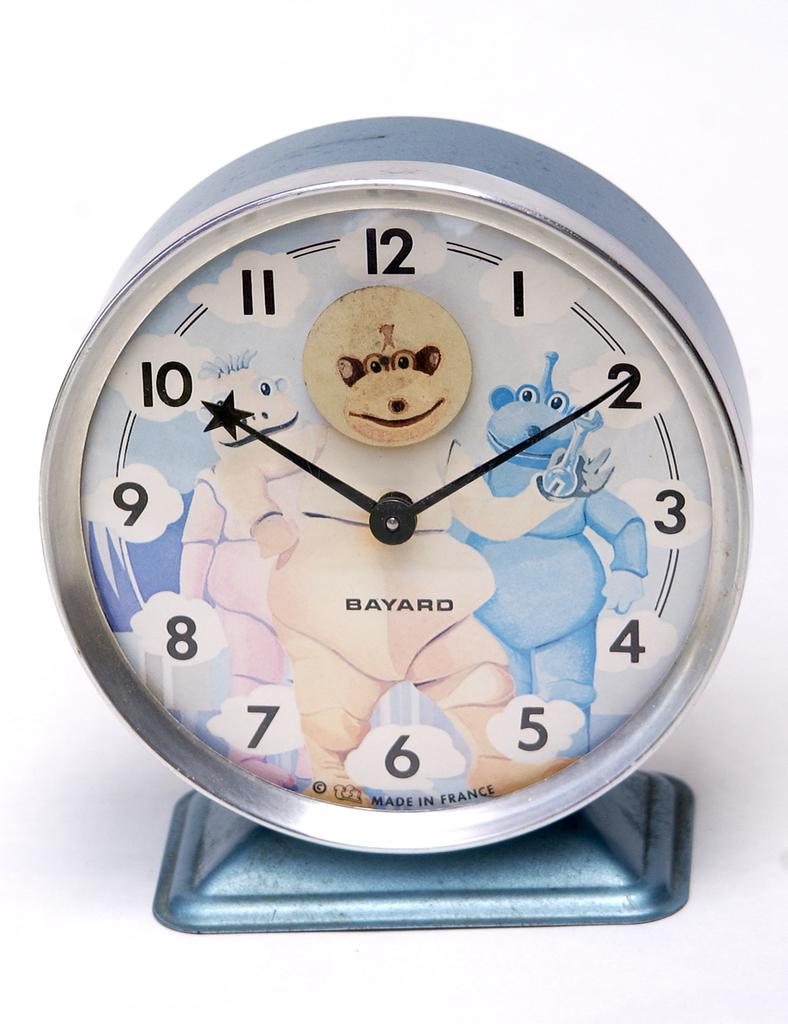Provide a one-sentence caption for the provided image. The clock is from Bayard and has a blue monster on it. 